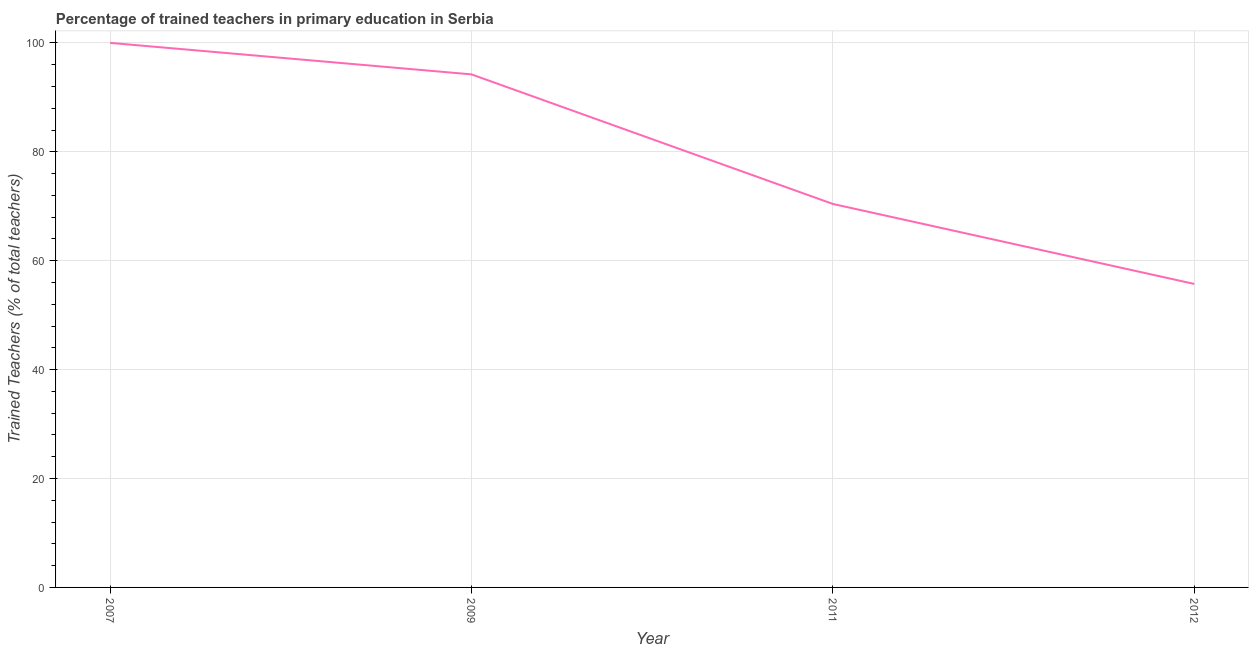What is the percentage of trained teachers in 2011?
Provide a short and direct response. 70.42. Across all years, what is the minimum percentage of trained teachers?
Give a very brief answer. 55.73. What is the sum of the percentage of trained teachers?
Your response must be concise. 320.37. What is the difference between the percentage of trained teachers in 2011 and 2012?
Provide a succinct answer. 14.69. What is the average percentage of trained teachers per year?
Your answer should be very brief. 80.09. What is the median percentage of trained teachers?
Your response must be concise. 82.32. In how many years, is the percentage of trained teachers greater than 44 %?
Your response must be concise. 4. What is the ratio of the percentage of trained teachers in 2007 to that in 2012?
Provide a short and direct response. 1.79. Is the percentage of trained teachers in 2011 less than that in 2012?
Provide a succinct answer. No. What is the difference between the highest and the second highest percentage of trained teachers?
Offer a terse response. 5.78. What is the difference between the highest and the lowest percentage of trained teachers?
Provide a short and direct response. 44.27. How many lines are there?
Offer a very short reply. 1. How many years are there in the graph?
Provide a short and direct response. 4. What is the difference between two consecutive major ticks on the Y-axis?
Ensure brevity in your answer.  20. Are the values on the major ticks of Y-axis written in scientific E-notation?
Your answer should be very brief. No. Does the graph contain grids?
Provide a succinct answer. Yes. What is the title of the graph?
Ensure brevity in your answer.  Percentage of trained teachers in primary education in Serbia. What is the label or title of the Y-axis?
Provide a short and direct response. Trained Teachers (% of total teachers). What is the Trained Teachers (% of total teachers) of 2007?
Give a very brief answer. 100. What is the Trained Teachers (% of total teachers) of 2009?
Offer a very short reply. 94.22. What is the Trained Teachers (% of total teachers) in 2011?
Provide a succinct answer. 70.42. What is the Trained Teachers (% of total teachers) of 2012?
Give a very brief answer. 55.73. What is the difference between the Trained Teachers (% of total teachers) in 2007 and 2009?
Provide a short and direct response. 5.78. What is the difference between the Trained Teachers (% of total teachers) in 2007 and 2011?
Keep it short and to the point. 29.58. What is the difference between the Trained Teachers (% of total teachers) in 2007 and 2012?
Your answer should be very brief. 44.27. What is the difference between the Trained Teachers (% of total teachers) in 2009 and 2011?
Offer a terse response. 23.8. What is the difference between the Trained Teachers (% of total teachers) in 2009 and 2012?
Keep it short and to the point. 38.48. What is the difference between the Trained Teachers (% of total teachers) in 2011 and 2012?
Your response must be concise. 14.69. What is the ratio of the Trained Teachers (% of total teachers) in 2007 to that in 2009?
Your answer should be very brief. 1.06. What is the ratio of the Trained Teachers (% of total teachers) in 2007 to that in 2011?
Provide a succinct answer. 1.42. What is the ratio of the Trained Teachers (% of total teachers) in 2007 to that in 2012?
Your answer should be very brief. 1.79. What is the ratio of the Trained Teachers (% of total teachers) in 2009 to that in 2011?
Provide a succinct answer. 1.34. What is the ratio of the Trained Teachers (% of total teachers) in 2009 to that in 2012?
Ensure brevity in your answer.  1.69. What is the ratio of the Trained Teachers (% of total teachers) in 2011 to that in 2012?
Ensure brevity in your answer.  1.26. 